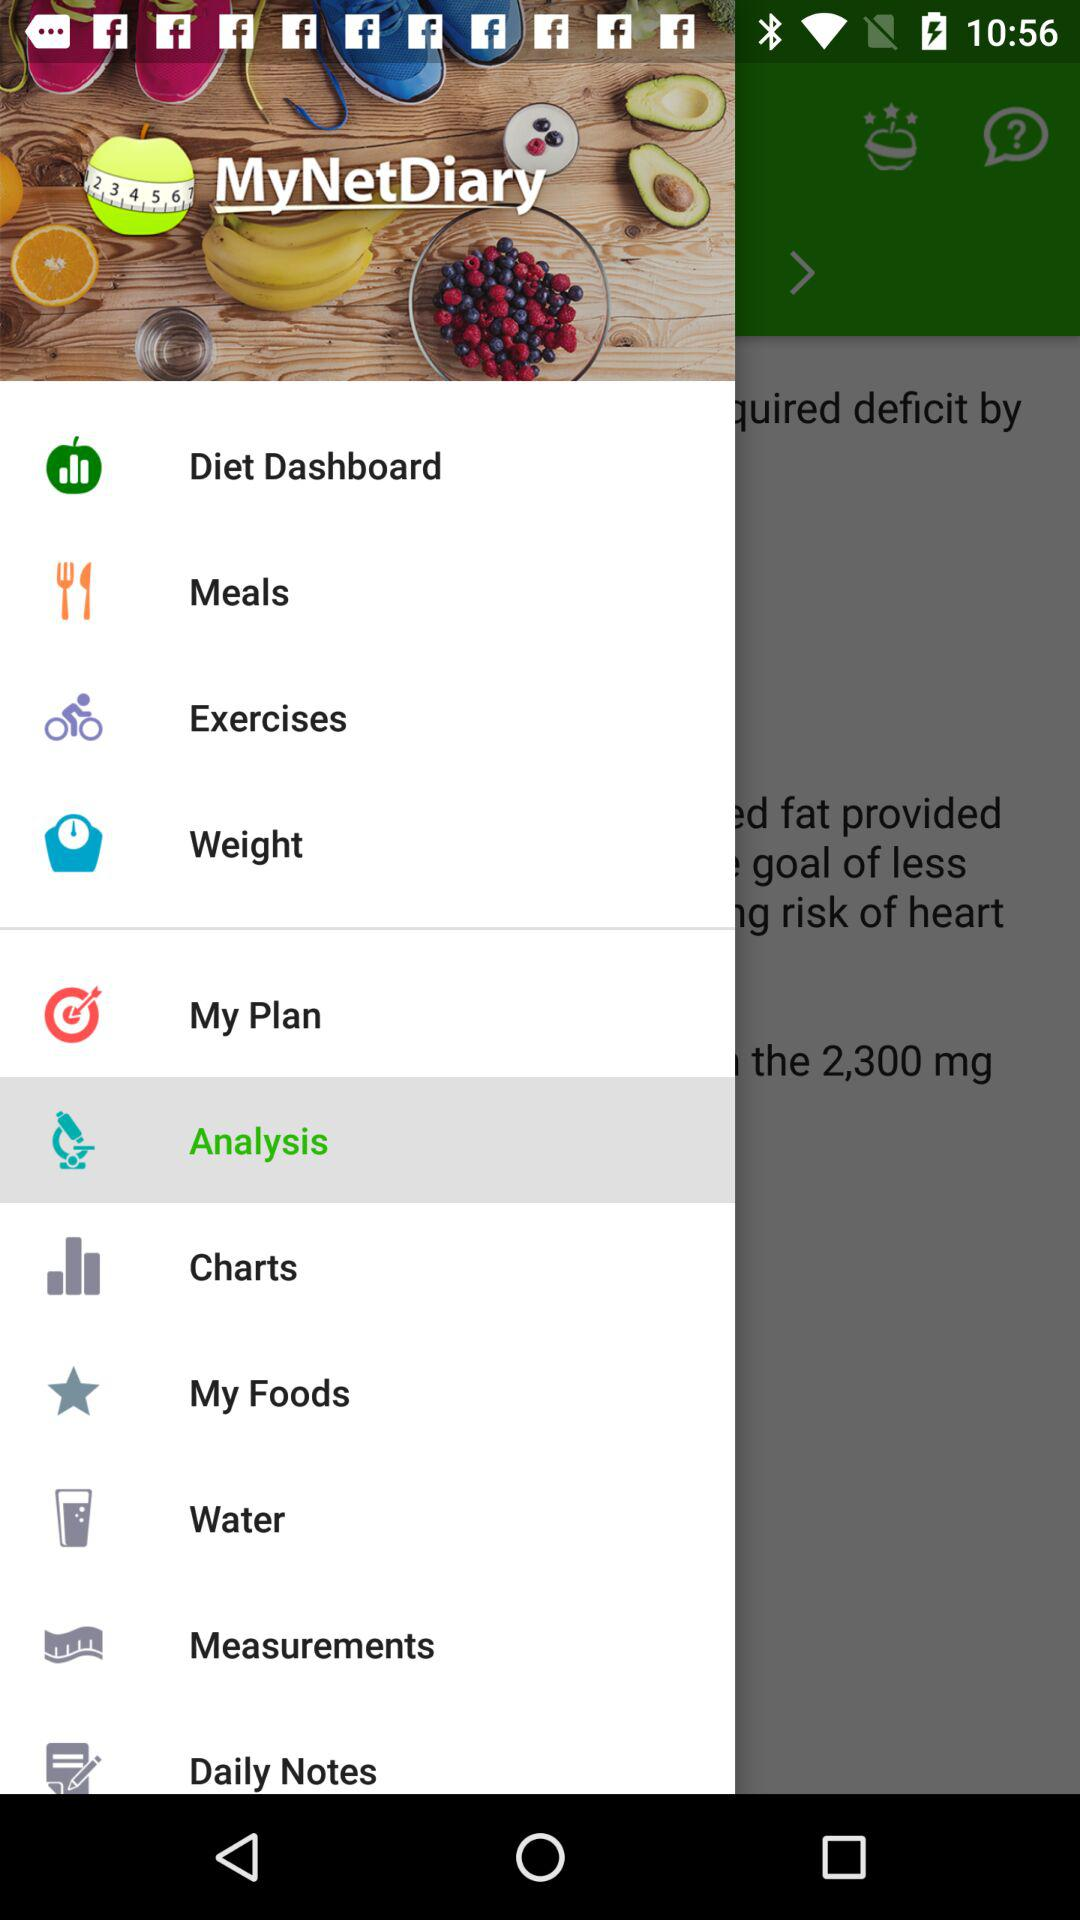What is the application name? The application name is "MyNetDiary". 